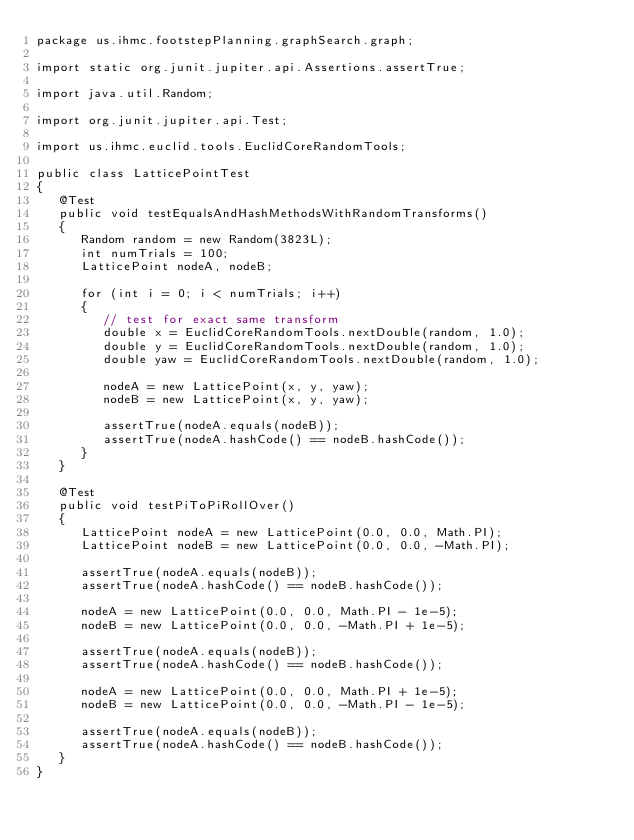Convert code to text. <code><loc_0><loc_0><loc_500><loc_500><_Java_>package us.ihmc.footstepPlanning.graphSearch.graph;

import static org.junit.jupiter.api.Assertions.assertTrue;

import java.util.Random;

import org.junit.jupiter.api.Test;

import us.ihmc.euclid.tools.EuclidCoreRandomTools;

public class LatticePointTest
{
   @Test
   public void testEqualsAndHashMethodsWithRandomTransforms()
   {
      Random random = new Random(3823L);
      int numTrials = 100;
      LatticePoint nodeA, nodeB;

      for (int i = 0; i < numTrials; i++)
      {
         // test for exact same transform
         double x = EuclidCoreRandomTools.nextDouble(random, 1.0);
         double y = EuclidCoreRandomTools.nextDouble(random, 1.0);
         double yaw = EuclidCoreRandomTools.nextDouble(random, 1.0);

         nodeA = new LatticePoint(x, y, yaw);
         nodeB = new LatticePoint(x, y, yaw);

         assertTrue(nodeA.equals(nodeB));
         assertTrue(nodeA.hashCode() == nodeB.hashCode());
      }
   }

   @Test
   public void testPiToPiRollOver()
   {
      LatticePoint nodeA = new LatticePoint(0.0, 0.0, Math.PI);
      LatticePoint nodeB = new LatticePoint(0.0, 0.0, -Math.PI);

      assertTrue(nodeA.equals(nodeB));
      assertTrue(nodeA.hashCode() == nodeB.hashCode());

      nodeA = new LatticePoint(0.0, 0.0, Math.PI - 1e-5);
      nodeB = new LatticePoint(0.0, 0.0, -Math.PI + 1e-5);

      assertTrue(nodeA.equals(nodeB));
      assertTrue(nodeA.hashCode() == nodeB.hashCode());

      nodeA = new LatticePoint(0.0, 0.0, Math.PI + 1e-5);
      nodeB = new LatticePoint(0.0, 0.0, -Math.PI - 1e-5);

      assertTrue(nodeA.equals(nodeB));
      assertTrue(nodeA.hashCode() == nodeB.hashCode());
   }
}
</code> 